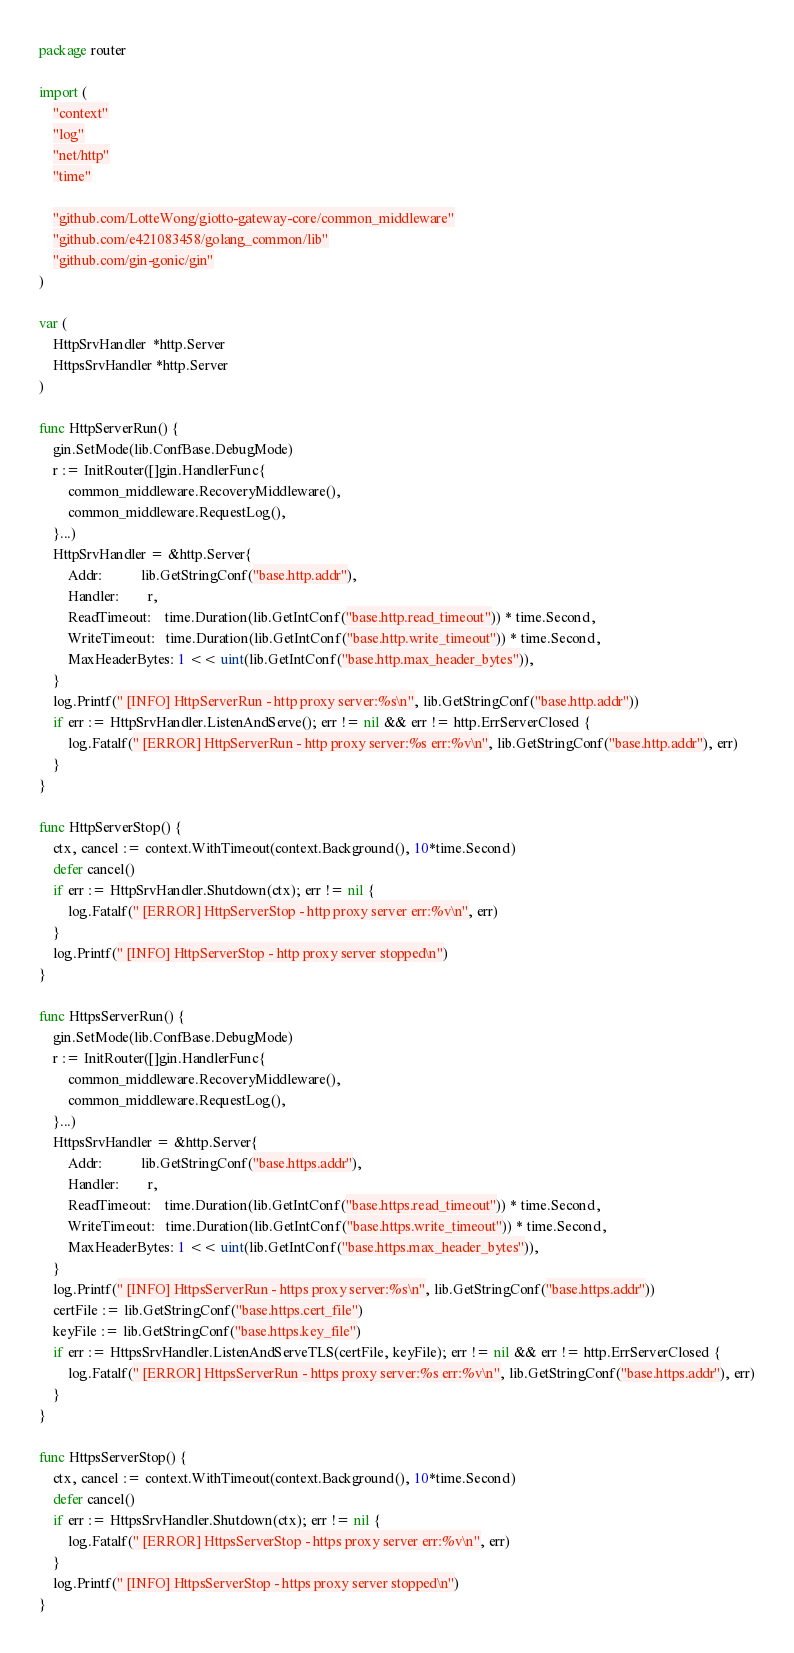Convert code to text. <code><loc_0><loc_0><loc_500><loc_500><_Go_>package router

import (
	"context"
	"log"
	"net/http"
	"time"

	"github.com/LotteWong/giotto-gateway-core/common_middleware"
	"github.com/e421083458/golang_common/lib"
	"github.com/gin-gonic/gin"
)

var (
	HttpSrvHandler  *http.Server
	HttpsSrvHandler *http.Server
)

func HttpServerRun() {
	gin.SetMode(lib.ConfBase.DebugMode)
	r := InitRouter([]gin.HandlerFunc{
		common_middleware.RecoveryMiddleware(),
		common_middleware.RequestLog(),
	}...)
	HttpSrvHandler = &http.Server{
		Addr:           lib.GetStringConf("base.http.addr"),
		Handler:        r,
		ReadTimeout:    time.Duration(lib.GetIntConf("base.http.read_timeout")) * time.Second,
		WriteTimeout:   time.Duration(lib.GetIntConf("base.http.write_timeout")) * time.Second,
		MaxHeaderBytes: 1 << uint(lib.GetIntConf("base.http.max_header_bytes")),
	}
	log.Printf(" [INFO] HttpServerRun - http proxy server:%s\n", lib.GetStringConf("base.http.addr"))
	if err := HttpSrvHandler.ListenAndServe(); err != nil && err != http.ErrServerClosed {
		log.Fatalf(" [ERROR] HttpServerRun - http proxy server:%s err:%v\n", lib.GetStringConf("base.http.addr"), err)
	}
}

func HttpServerStop() {
	ctx, cancel := context.WithTimeout(context.Background(), 10*time.Second)
	defer cancel()
	if err := HttpSrvHandler.Shutdown(ctx); err != nil {
		log.Fatalf(" [ERROR] HttpServerStop - http proxy server err:%v\n", err)
	}
	log.Printf(" [INFO] HttpServerStop - http proxy server stopped\n")
}

func HttpsServerRun() {
	gin.SetMode(lib.ConfBase.DebugMode)
	r := InitRouter([]gin.HandlerFunc{
		common_middleware.RecoveryMiddleware(),
		common_middleware.RequestLog(),
	}...)
	HttpsSrvHandler = &http.Server{
		Addr:           lib.GetStringConf("base.https.addr"),
		Handler:        r,
		ReadTimeout:    time.Duration(lib.GetIntConf("base.https.read_timeout")) * time.Second,
		WriteTimeout:   time.Duration(lib.GetIntConf("base.https.write_timeout")) * time.Second,
		MaxHeaderBytes: 1 << uint(lib.GetIntConf("base.https.max_header_bytes")),
	}
	log.Printf(" [INFO] HttpsServerRun - https proxy server:%s\n", lib.GetStringConf("base.https.addr"))
	certFile := lib.GetStringConf("base.https.cert_file")
	keyFile := lib.GetStringConf("base.https.key_file")
	if err := HttpsSrvHandler.ListenAndServeTLS(certFile, keyFile); err != nil && err != http.ErrServerClosed {
		log.Fatalf(" [ERROR] HttpsServerRun - https proxy server:%s err:%v\n", lib.GetStringConf("base.https.addr"), err)
	}
}

func HttpsServerStop() {
	ctx, cancel := context.WithTimeout(context.Background(), 10*time.Second)
	defer cancel()
	if err := HttpsSrvHandler.Shutdown(ctx); err != nil {
		log.Fatalf(" [ERROR] HttpsServerStop - https proxy server err:%v\n", err)
	}
	log.Printf(" [INFO] HttpsServerStop - https proxy server stopped\n")
}
</code> 